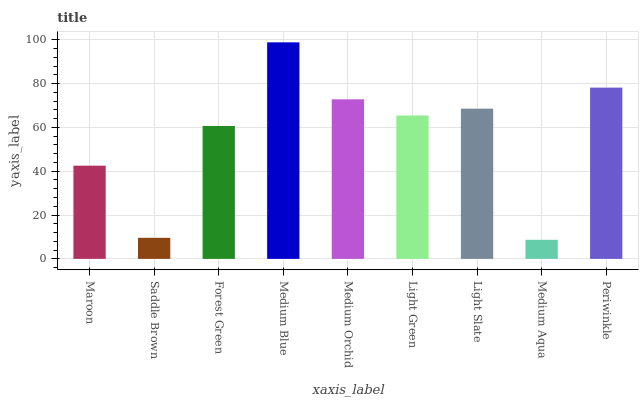Is Medium Aqua the minimum?
Answer yes or no. Yes. Is Medium Blue the maximum?
Answer yes or no. Yes. Is Saddle Brown the minimum?
Answer yes or no. No. Is Saddle Brown the maximum?
Answer yes or no. No. Is Maroon greater than Saddle Brown?
Answer yes or no. Yes. Is Saddle Brown less than Maroon?
Answer yes or no. Yes. Is Saddle Brown greater than Maroon?
Answer yes or no. No. Is Maroon less than Saddle Brown?
Answer yes or no. No. Is Light Green the high median?
Answer yes or no. Yes. Is Light Green the low median?
Answer yes or no. Yes. Is Medium Aqua the high median?
Answer yes or no. No. Is Maroon the low median?
Answer yes or no. No. 